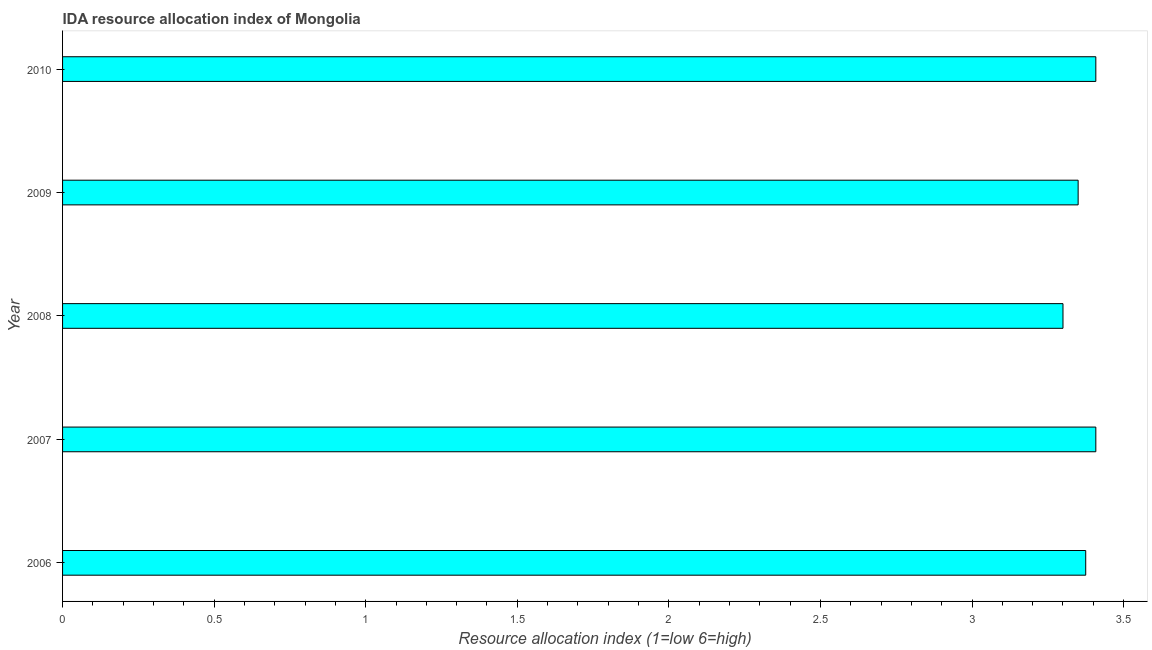Does the graph contain grids?
Your response must be concise. No. What is the title of the graph?
Keep it short and to the point. IDA resource allocation index of Mongolia. What is the label or title of the X-axis?
Give a very brief answer. Resource allocation index (1=low 6=high). What is the label or title of the Y-axis?
Ensure brevity in your answer.  Year. What is the ida resource allocation index in 2009?
Make the answer very short. 3.35. Across all years, what is the maximum ida resource allocation index?
Your answer should be very brief. 3.41. Across all years, what is the minimum ida resource allocation index?
Provide a short and direct response. 3.3. In which year was the ida resource allocation index maximum?
Give a very brief answer. 2007. What is the sum of the ida resource allocation index?
Make the answer very short. 16.84. What is the difference between the ida resource allocation index in 2007 and 2010?
Give a very brief answer. 0. What is the average ida resource allocation index per year?
Your answer should be very brief. 3.37. What is the median ida resource allocation index?
Your response must be concise. 3.38. In how many years, is the ida resource allocation index greater than 1.7 ?
Offer a terse response. 5. Do a majority of the years between 2009 and 2007 (inclusive) have ida resource allocation index greater than 0.7 ?
Offer a very short reply. Yes. Is the ida resource allocation index in 2006 less than that in 2007?
Your answer should be compact. Yes. What is the difference between the highest and the second highest ida resource allocation index?
Your response must be concise. 0. Is the sum of the ida resource allocation index in 2009 and 2010 greater than the maximum ida resource allocation index across all years?
Your response must be concise. Yes. What is the difference between the highest and the lowest ida resource allocation index?
Offer a terse response. 0.11. How many years are there in the graph?
Keep it short and to the point. 5. What is the difference between two consecutive major ticks on the X-axis?
Provide a short and direct response. 0.5. Are the values on the major ticks of X-axis written in scientific E-notation?
Your answer should be compact. No. What is the Resource allocation index (1=low 6=high) in 2006?
Give a very brief answer. 3.38. What is the Resource allocation index (1=low 6=high) in 2007?
Your answer should be very brief. 3.41. What is the Resource allocation index (1=low 6=high) in 2008?
Provide a succinct answer. 3.3. What is the Resource allocation index (1=low 6=high) in 2009?
Provide a short and direct response. 3.35. What is the Resource allocation index (1=low 6=high) of 2010?
Your answer should be very brief. 3.41. What is the difference between the Resource allocation index (1=low 6=high) in 2006 and 2007?
Your answer should be compact. -0.03. What is the difference between the Resource allocation index (1=low 6=high) in 2006 and 2008?
Ensure brevity in your answer.  0.07. What is the difference between the Resource allocation index (1=low 6=high) in 2006 and 2009?
Offer a terse response. 0.03. What is the difference between the Resource allocation index (1=low 6=high) in 2006 and 2010?
Your answer should be compact. -0.03. What is the difference between the Resource allocation index (1=low 6=high) in 2007 and 2008?
Your answer should be compact. 0.11. What is the difference between the Resource allocation index (1=low 6=high) in 2007 and 2009?
Make the answer very short. 0.06. What is the difference between the Resource allocation index (1=low 6=high) in 2007 and 2010?
Make the answer very short. 0. What is the difference between the Resource allocation index (1=low 6=high) in 2008 and 2010?
Give a very brief answer. -0.11. What is the difference between the Resource allocation index (1=low 6=high) in 2009 and 2010?
Make the answer very short. -0.06. What is the ratio of the Resource allocation index (1=low 6=high) in 2006 to that in 2007?
Provide a succinct answer. 0.99. What is the ratio of the Resource allocation index (1=low 6=high) in 2006 to that in 2010?
Offer a terse response. 0.99. What is the ratio of the Resource allocation index (1=low 6=high) in 2007 to that in 2008?
Provide a succinct answer. 1.03. What is the ratio of the Resource allocation index (1=low 6=high) in 2007 to that in 2009?
Give a very brief answer. 1.02. What is the ratio of the Resource allocation index (1=low 6=high) in 2008 to that in 2009?
Your response must be concise. 0.98. What is the ratio of the Resource allocation index (1=low 6=high) in 2008 to that in 2010?
Your answer should be compact. 0.97. 